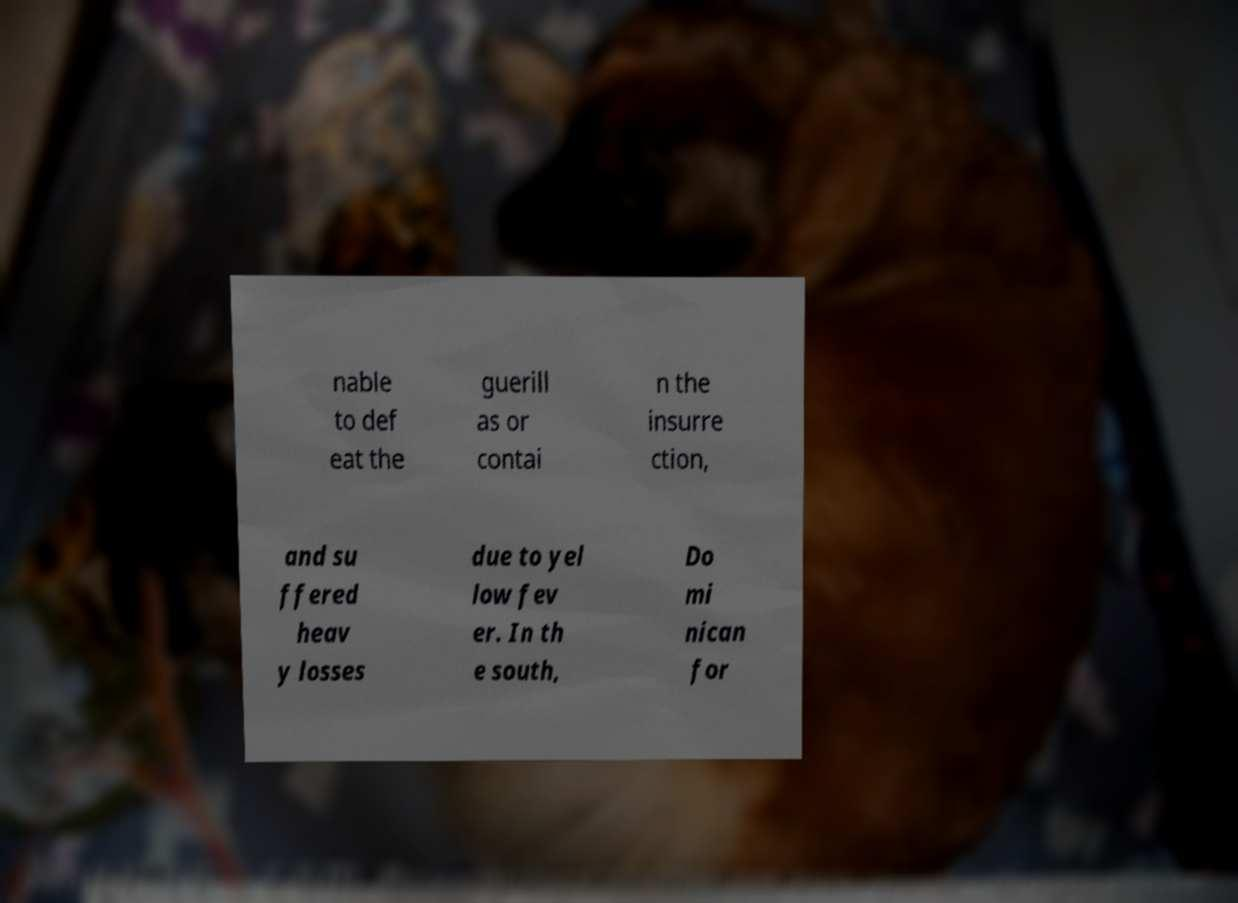I need the written content from this picture converted into text. Can you do that? nable to def eat the guerill as or contai n the insurre ction, and su ffered heav y losses due to yel low fev er. In th e south, Do mi nican for 